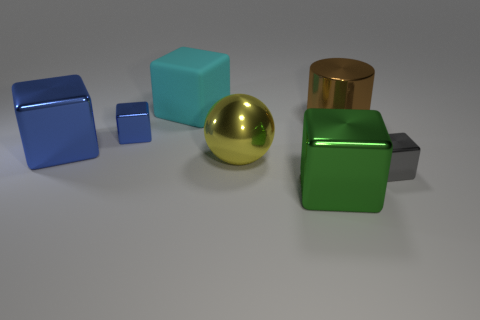Subtract all big blue shiny cubes. How many cubes are left? 4 Subtract all green blocks. How many blocks are left? 4 Add 2 yellow metal things. How many objects exist? 9 Subtract 1 cylinders. How many cylinders are left? 0 Add 6 tiny gray shiny things. How many tiny gray shiny things exist? 7 Subtract 1 yellow balls. How many objects are left? 6 Subtract all blocks. How many objects are left? 2 Subtract all green balls. Subtract all cyan cylinders. How many balls are left? 1 Subtract all yellow spheres. How many gray cubes are left? 1 Subtract all small gray things. Subtract all green things. How many objects are left? 5 